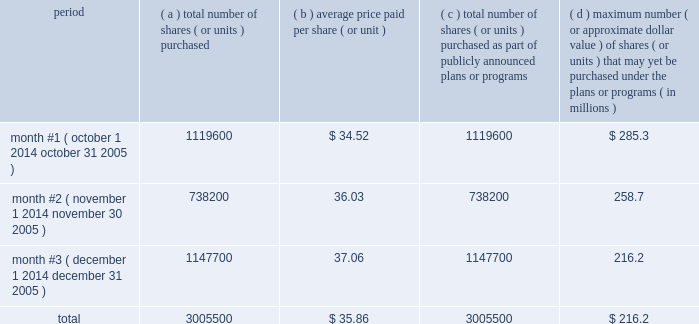Issuer purchases of equity securities period total number of shares ( or units ) purchased average price paid per share ( or unit ) total number of shares ( or units ) purchased as part of publicly announced plans or programs maximum number ( or approximate dollar value ) of shares ( or units ) that may yet be purchased under the plans or programs ( in millions ) month #1 ( october 1 , 2014 october 31 , 2005 ) .
1119600 $ 34.52 1119600 $ 285.3 month #2 ( november 1 , 2014 november 30 , 2005 ) .
738200 36.03 738200 258.7 month #3 ( december 1 , 2014 december 31 , 2005 ) .
1147700 37.06 1147700 216.2 .
The share purchases reflected in the table above were made pursuant to our $ 500.0 million repurchase program approved by our board of directors in april 2005 .
This share repurchase program does not have an expiration date .
No share repurchase program approved by our board of directors has ever expired nor do we expect to terminate any program prior to completion .
We intend to make additional share purchases under our existing repurchase program up to an aggregate of $ 216.2 million and under the additional $ 275.0 million program authorized by our board of directors in january 2006. .
What was the percent of the period month #1 ( october 1 2014 october 31 2005 ) as part of the total of total number of shares ( or units ) purchased? 
Rationale: the percent of the period month #1 ( october 1 2014 october 31 2005 ) as part of the total of total number of shares ( or units ) purchased was 37.3 of the total amount
Computations: (1119600 / 3005500)
Answer: 0.37252. 